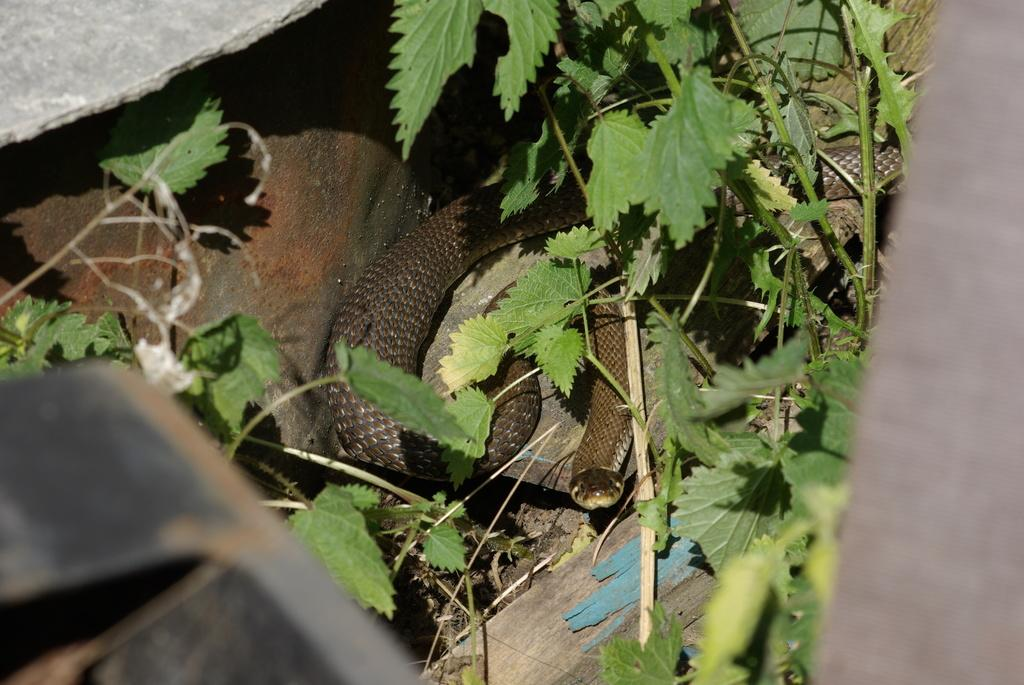What type of animal is in the image? There is a snake in the image. What other living organism can be seen in the image? There is a plant in the image. What type of floor can be seen in the image? There is no floor visible in the image; it only shows a snake and a plant. What type of butter is being used to feed the snake in the image? There is no butter present in the image, and the snake is not being fed. 